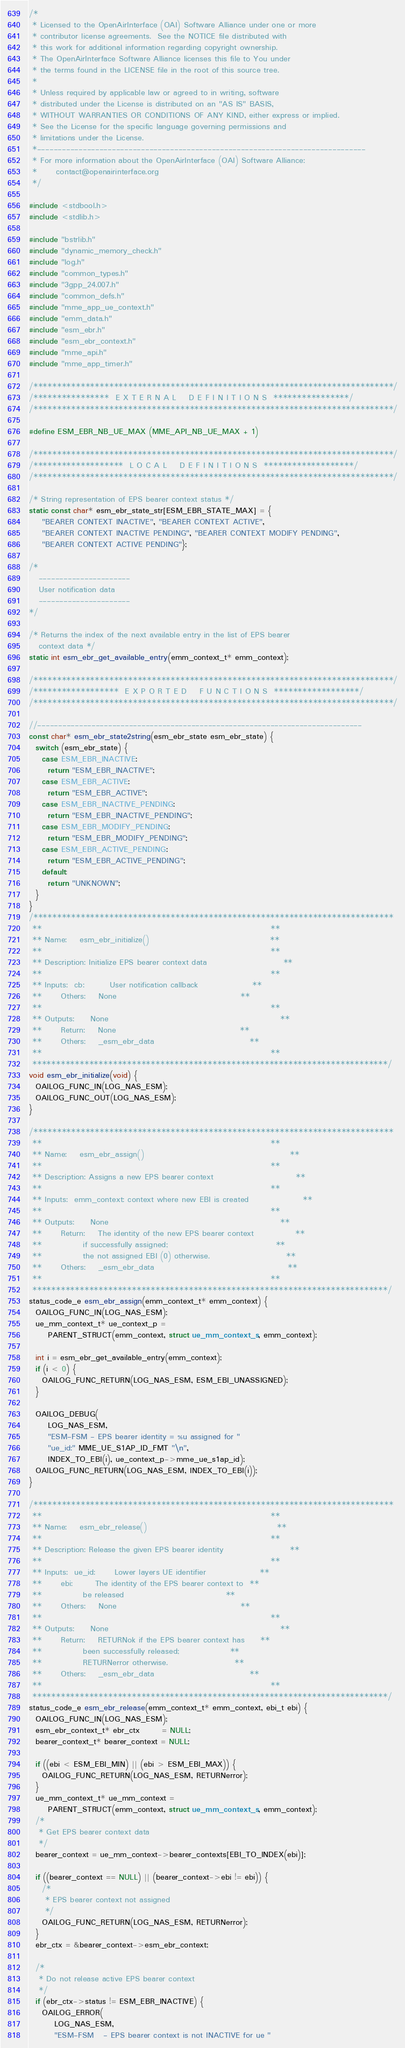<code> <loc_0><loc_0><loc_500><loc_500><_C_>/*
 * Licensed to the OpenAirInterface (OAI) Software Alliance under one or more
 * contributor license agreements.  See the NOTICE file distributed with
 * this work for additional information regarding copyright ownership.
 * The OpenAirInterface Software Alliance licenses this file to You under
 * the terms found in the LICENSE file in the root of this source tree.
 *
 * Unless required by applicable law or agreed to in writing, software
 * distributed under the License is distributed on an "AS IS" BASIS,
 * WITHOUT WARRANTIES OR CONDITIONS OF ANY KIND, either express or implied.
 * See the License for the specific language governing permissions and
 * limitations under the License.
 *-------------------------------------------------------------------------------
 * For more information about the OpenAirInterface (OAI) Software Alliance:
 *      contact@openairinterface.org
 */

#include <stdbool.h>
#include <stdlib.h>

#include "bstrlib.h"
#include "dynamic_memory_check.h"
#include "log.h"
#include "common_types.h"
#include "3gpp_24.007.h"
#include "common_defs.h"
#include "mme_app_ue_context.h"
#include "emm_data.h"
#include "esm_ebr.h"
#include "esm_ebr_context.h"
#include "mme_api.h"
#include "mme_app_timer.h"

/****************************************************************************/
/****************  E X T E R N A L    D E F I N I T I O N S  ****************/
/****************************************************************************/

#define ESM_EBR_NB_UE_MAX (MME_API_NB_UE_MAX + 1)

/****************************************************************************/
/*******************  L O C A L    D E F I N I T I O N S  *******************/
/****************************************************************************/

/* String representation of EPS bearer context status */
static const char* esm_ebr_state_str[ESM_EBR_STATE_MAX] = {
    "BEARER CONTEXT INACTIVE", "BEARER CONTEXT ACTIVE",
    "BEARER CONTEXT INACTIVE PENDING", "BEARER CONTEXT MODIFY PENDING",
    "BEARER CONTEXT ACTIVE PENDING"};

/*
   ----------------------
   User notification data
   ----------------------
*/

/* Returns the index of the next available entry in the list of EPS bearer
   context data */
static int esm_ebr_get_available_entry(emm_context_t* emm_context);

/****************************************************************************/
/******************  E X P O R T E D    F U N C T I O N S  ******************/
/****************************************************************************/

//------------------------------------------------------------------------------
const char* esm_ebr_state2string(esm_ebr_state esm_ebr_state) {
  switch (esm_ebr_state) {
    case ESM_EBR_INACTIVE:
      return "ESM_EBR_INACTIVE";
    case ESM_EBR_ACTIVE:
      return "ESM_EBR_ACTIVE";
    case ESM_EBR_INACTIVE_PENDING:
      return "ESM_EBR_INACTIVE_PENDING";
    case ESM_EBR_MODIFY_PENDING:
      return "ESM_EBR_MODIFY_PENDING";
    case ESM_EBR_ACTIVE_PENDING:
      return "ESM_EBR_ACTIVE_PENDING";
    default:
      return "UNKNOWN";
  }
}
/****************************************************************************
 **                                                                        **
 ** Name:    esm_ebr_initialize()                                      **
 **                                                                        **
 ** Description: Initialize EPS bearer context data                        **
 **                                                                        **
 ** Inputs:  cb:        User notification callback                 **
 **      Others:    None                                       **
 **                                                                        **
 ** Outputs:     None                                                      **
 **      Return:    None                                       **
 **      Others:    _esm_ebr_data                              **
 **                                                                        **
 ***************************************************************************/
void esm_ebr_initialize(void) {
  OAILOG_FUNC_IN(LOG_NAS_ESM);
  OAILOG_FUNC_OUT(LOG_NAS_ESM);
}

/****************************************************************************
 **                                                                        **
 ** Name:    esm_ebr_assign()                                              **
 **                                                                        **
 ** Description: Assigns a new EPS bearer context                          **
 **                                                                        **
 ** Inputs:  emm_context: context where new EBI is created                 **
 **                                                                        **
 ** Outputs:     None                                                      **
 **      Return:    The identity of the new EPS bearer context             **
 **             if successfully assigned;                                  **
 **             the not assigned EBI (0) otherwise.                        **
 **      Others:    _esm_ebr_data                                          **
 **                                                                        **
 ***************************************************************************/
status_code_e esm_ebr_assign(emm_context_t* emm_context) {
  OAILOG_FUNC_IN(LOG_NAS_ESM);
  ue_mm_context_t* ue_context_p =
      PARENT_STRUCT(emm_context, struct ue_mm_context_s, emm_context);

  int i = esm_ebr_get_available_entry(emm_context);
  if (i < 0) {
    OAILOG_FUNC_RETURN(LOG_NAS_ESM, ESM_EBI_UNASSIGNED);
  }

  OAILOG_DEBUG(
      LOG_NAS_ESM,
      "ESM-FSM - EPS bearer identity = %u assigned for "
      "ue_id:" MME_UE_S1AP_ID_FMT "\n",
      INDEX_TO_EBI(i), ue_context_p->mme_ue_s1ap_id);
  OAILOG_FUNC_RETURN(LOG_NAS_ESM, INDEX_TO_EBI(i));
}

/****************************************************************************
 **                                                                        **
 ** Name:    esm_ebr_release()                                         **
 **                                                                        **
 ** Description: Release the given EPS bearer identity                     **
 **                                                                        **
 ** Inputs:  ue_id:      Lower layers UE identifier                 **
 **      ebi:       The identity of the EPS bearer context to  **
 **             be released                                **
 **      Others:    None                                       **
 **                                                                        **
 ** Outputs:     None                                                      **
 **      Return:    RETURNok if the EPS bearer context has     **
 **             been successfully released;                **
 **             RETURNerror otherwise.                     **
 **      Others:    _esm_ebr_data                              **
 **                                                                        **
 ***************************************************************************/
status_code_e esm_ebr_release(emm_context_t* emm_context, ebi_t ebi) {
  OAILOG_FUNC_IN(LOG_NAS_ESM);
  esm_ebr_context_t* ebr_ctx       = NULL;
  bearer_context_t* bearer_context = NULL;

  if ((ebi < ESM_EBI_MIN) || (ebi > ESM_EBI_MAX)) {
    OAILOG_FUNC_RETURN(LOG_NAS_ESM, RETURNerror);
  }
  ue_mm_context_t* ue_mm_context =
      PARENT_STRUCT(emm_context, struct ue_mm_context_s, emm_context);
  /*
   * Get EPS bearer context data
   */
  bearer_context = ue_mm_context->bearer_contexts[EBI_TO_INDEX(ebi)];

  if ((bearer_context == NULL) || (bearer_context->ebi != ebi)) {
    /*
     * EPS bearer context not assigned
     */
    OAILOG_FUNC_RETURN(LOG_NAS_ESM, RETURNerror);
  }
  ebr_ctx = &bearer_context->esm_ebr_context;

  /*
   * Do not release active EPS bearer context
   */
  if (ebr_ctx->status != ESM_EBR_INACTIVE) {
    OAILOG_ERROR(
        LOG_NAS_ESM,
        "ESM-FSM   - EPS bearer context is not INACTIVE for ue "</code> 